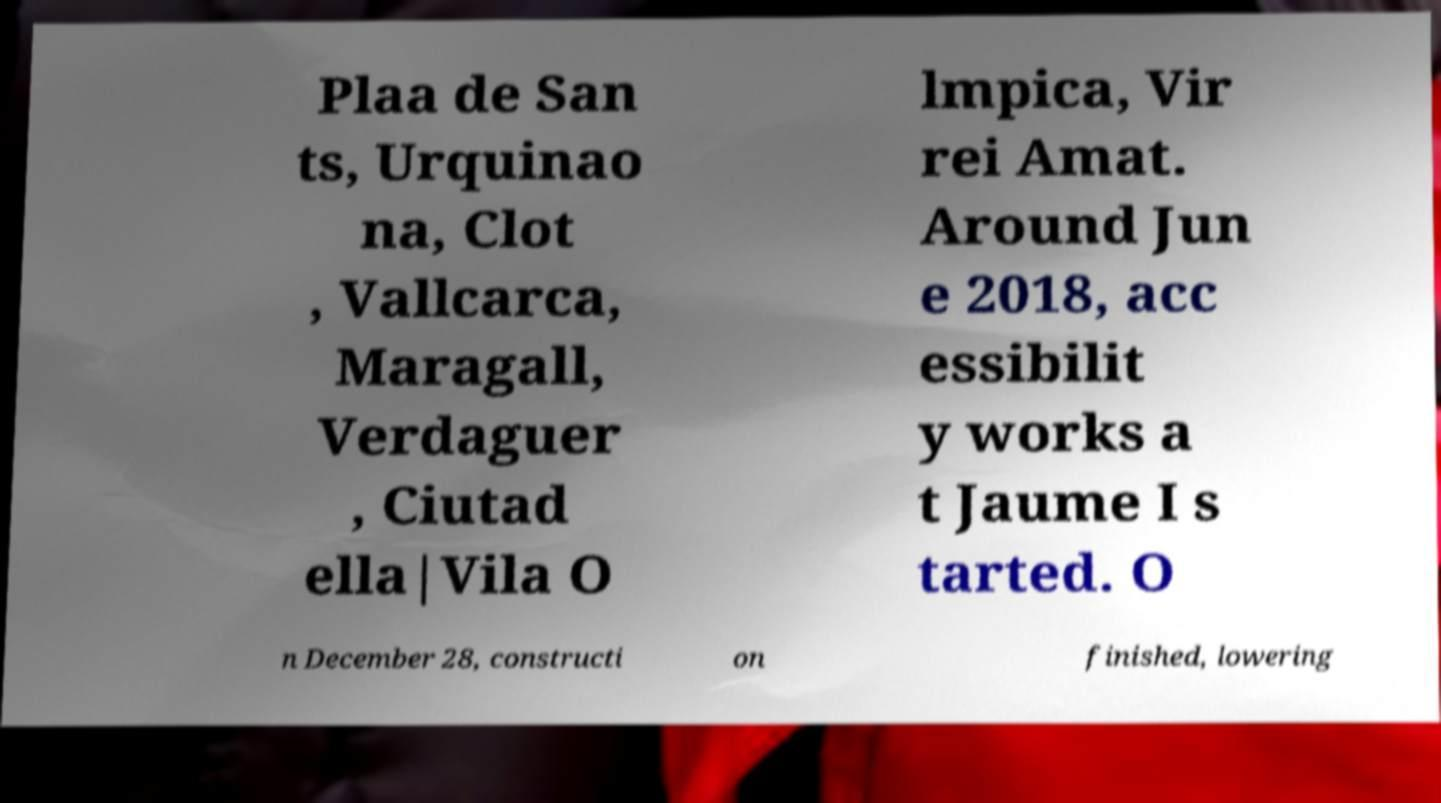For documentation purposes, I need the text within this image transcribed. Could you provide that? Plaa de San ts, Urquinao na, Clot , Vallcarca, Maragall, Verdaguer , Ciutad ella|Vila O lmpica, Vir rei Amat. Around Jun e 2018, acc essibilit y works a t Jaume I s tarted. O n December 28, constructi on finished, lowering 